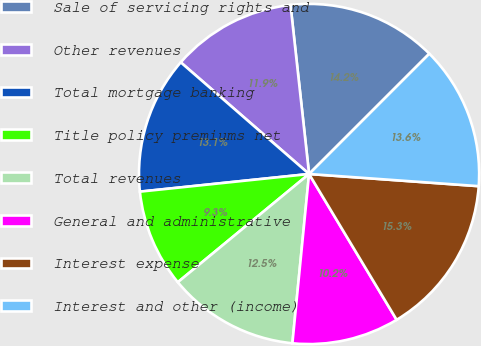<chart> <loc_0><loc_0><loc_500><loc_500><pie_chart><fcel>Sale of servicing rights and<fcel>Other revenues<fcel>Total mortgage banking<fcel>Title policy premiums net<fcel>Total revenues<fcel>General and administrative<fcel>Interest expense<fcel>Interest and other (income)<nl><fcel>14.24%<fcel>11.86%<fcel>13.05%<fcel>9.32%<fcel>12.46%<fcel>10.17%<fcel>15.25%<fcel>13.64%<nl></chart> 